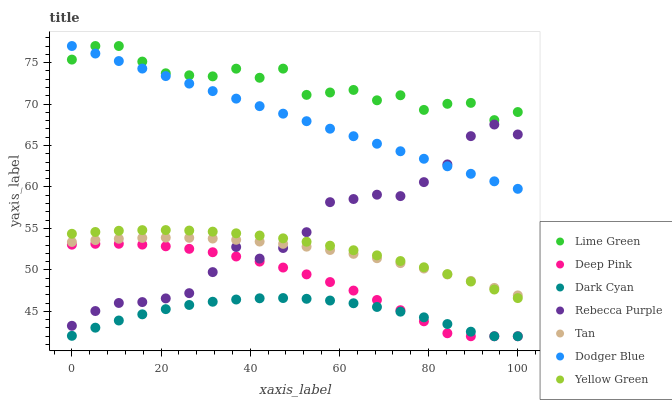Does Dark Cyan have the minimum area under the curve?
Answer yes or no. Yes. Does Lime Green have the maximum area under the curve?
Answer yes or no. Yes. Does Yellow Green have the minimum area under the curve?
Answer yes or no. No. Does Yellow Green have the maximum area under the curve?
Answer yes or no. No. Is Dodger Blue the smoothest?
Answer yes or no. Yes. Is Lime Green the roughest?
Answer yes or no. Yes. Is Yellow Green the smoothest?
Answer yes or no. No. Is Yellow Green the roughest?
Answer yes or no. No. Does Deep Pink have the lowest value?
Answer yes or no. Yes. Does Yellow Green have the lowest value?
Answer yes or no. No. Does Lime Green have the highest value?
Answer yes or no. Yes. Does Yellow Green have the highest value?
Answer yes or no. No. Is Dark Cyan less than Lime Green?
Answer yes or no. Yes. Is Lime Green greater than Dark Cyan?
Answer yes or no. Yes. Does Deep Pink intersect Dark Cyan?
Answer yes or no. Yes. Is Deep Pink less than Dark Cyan?
Answer yes or no. No. Is Deep Pink greater than Dark Cyan?
Answer yes or no. No. Does Dark Cyan intersect Lime Green?
Answer yes or no. No. 